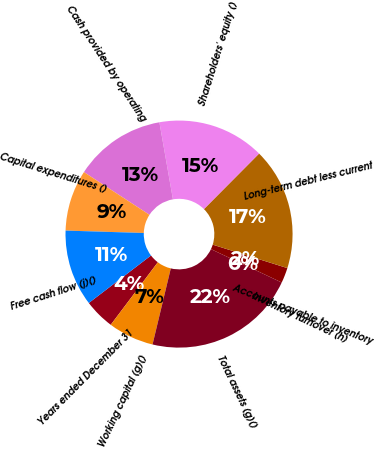Convert chart. <chart><loc_0><loc_0><loc_500><loc_500><pie_chart><fcel>Years ended December 31<fcel>Working capital (g)()<fcel>Total assets (g)()<fcel>Inventory turnover (h)<fcel>Accounts payable to inventory<fcel>Long-term debt less current<fcel>Shareholders' equity ()<fcel>Cash provided by operating<fcel>Capital expenditures ()<fcel>Free cash flow (j)()<nl><fcel>4.35%<fcel>6.52%<fcel>21.74%<fcel>0.0%<fcel>2.17%<fcel>17.39%<fcel>15.22%<fcel>13.04%<fcel>8.7%<fcel>10.87%<nl></chart> 